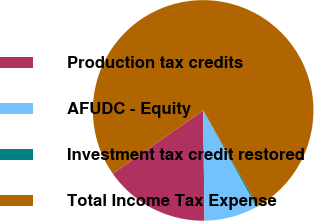Convert chart to OTSL. <chart><loc_0><loc_0><loc_500><loc_500><pie_chart><fcel>Production tax credits<fcel>AFUDC - Equity<fcel>Investment tax credit restored<fcel>Total Income Tax Expense<nl><fcel>15.47%<fcel>7.85%<fcel>0.23%<fcel>76.44%<nl></chart> 